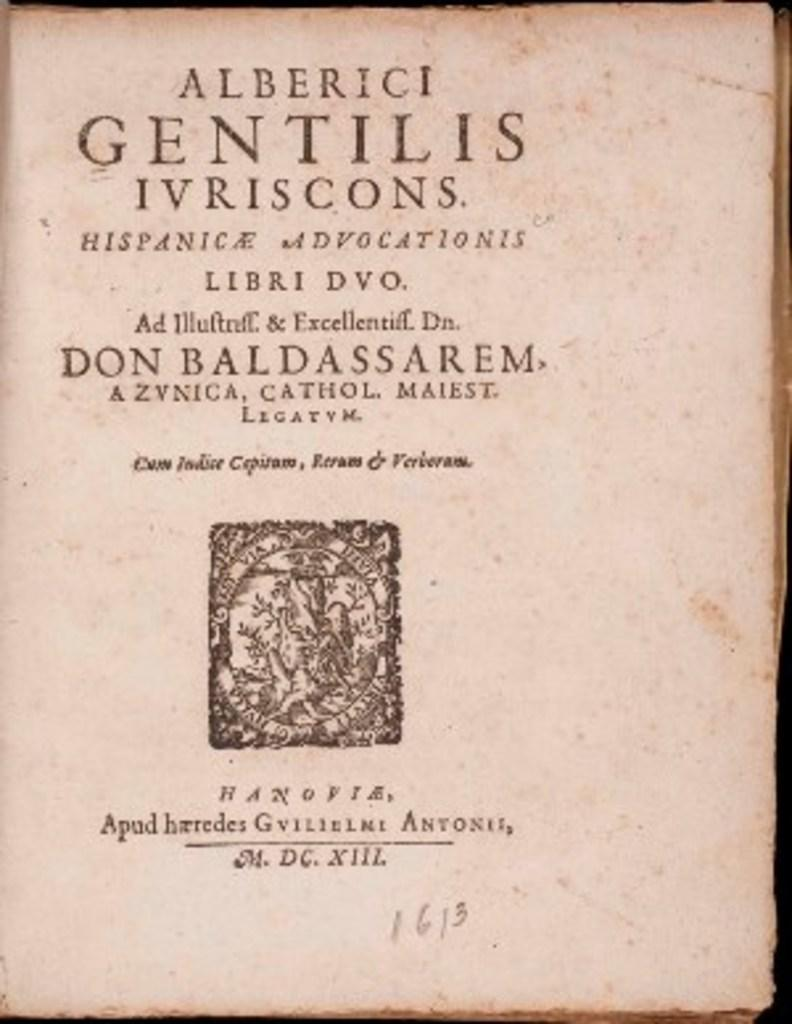Provide a one-sentence caption for the provided image. A book written by Alberici Gentilis Ivriscons and Don Baldassarem. 